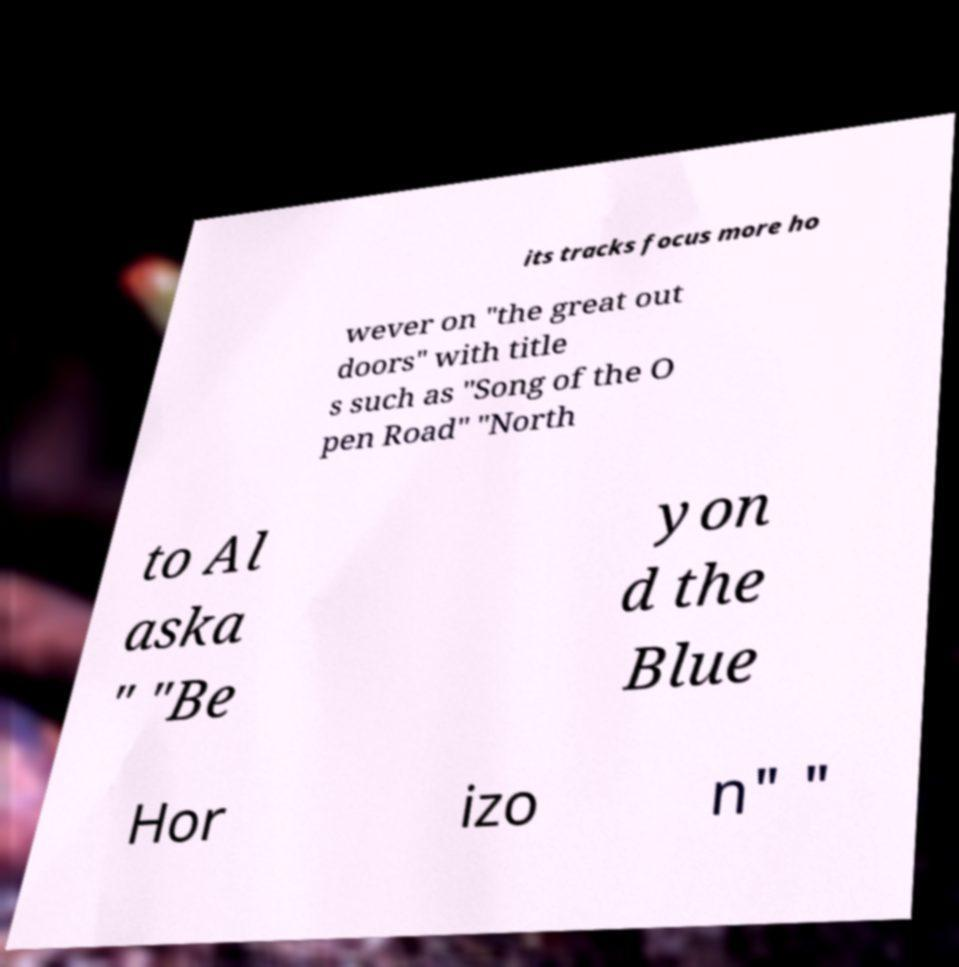Please identify and transcribe the text found in this image. its tracks focus more ho wever on "the great out doors" with title s such as "Song of the O pen Road" "North to Al aska " "Be yon d the Blue Hor izo n" " 